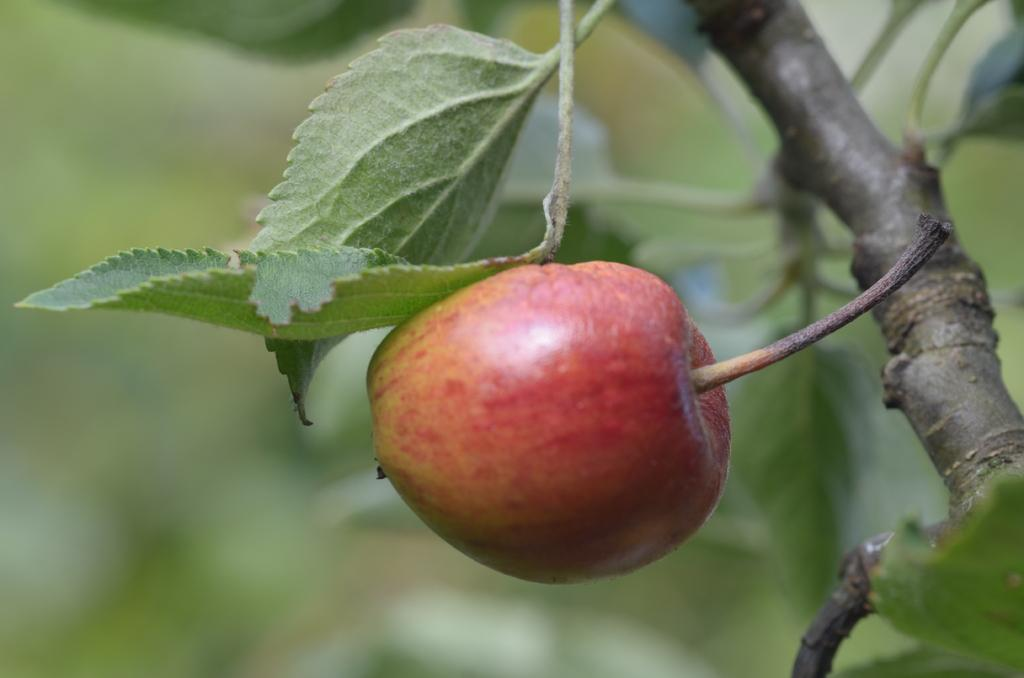What type of food is visible in the image? There is there a fruit in the image? What else can be seen in the image besides the fruit? There are leaves and a tree branch in the image. How would you describe the background of the image? The background of the image is blurred. How many vests are hanging from the tree branch in the image? There are no vests present in the image; it only features a fruit, leaves, and a tree branch. Can you see any mice running around the fruit in the image? There are no mice present in the image; it only features a fruit, leaves, and a tree branch. 